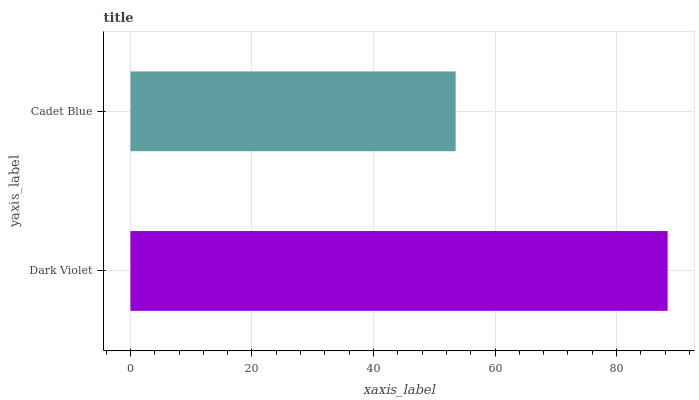Is Cadet Blue the minimum?
Answer yes or no. Yes. Is Dark Violet the maximum?
Answer yes or no. Yes. Is Cadet Blue the maximum?
Answer yes or no. No. Is Dark Violet greater than Cadet Blue?
Answer yes or no. Yes. Is Cadet Blue less than Dark Violet?
Answer yes or no. Yes. Is Cadet Blue greater than Dark Violet?
Answer yes or no. No. Is Dark Violet less than Cadet Blue?
Answer yes or no. No. Is Dark Violet the high median?
Answer yes or no. Yes. Is Cadet Blue the low median?
Answer yes or no. Yes. Is Cadet Blue the high median?
Answer yes or no. No. Is Dark Violet the low median?
Answer yes or no. No. 